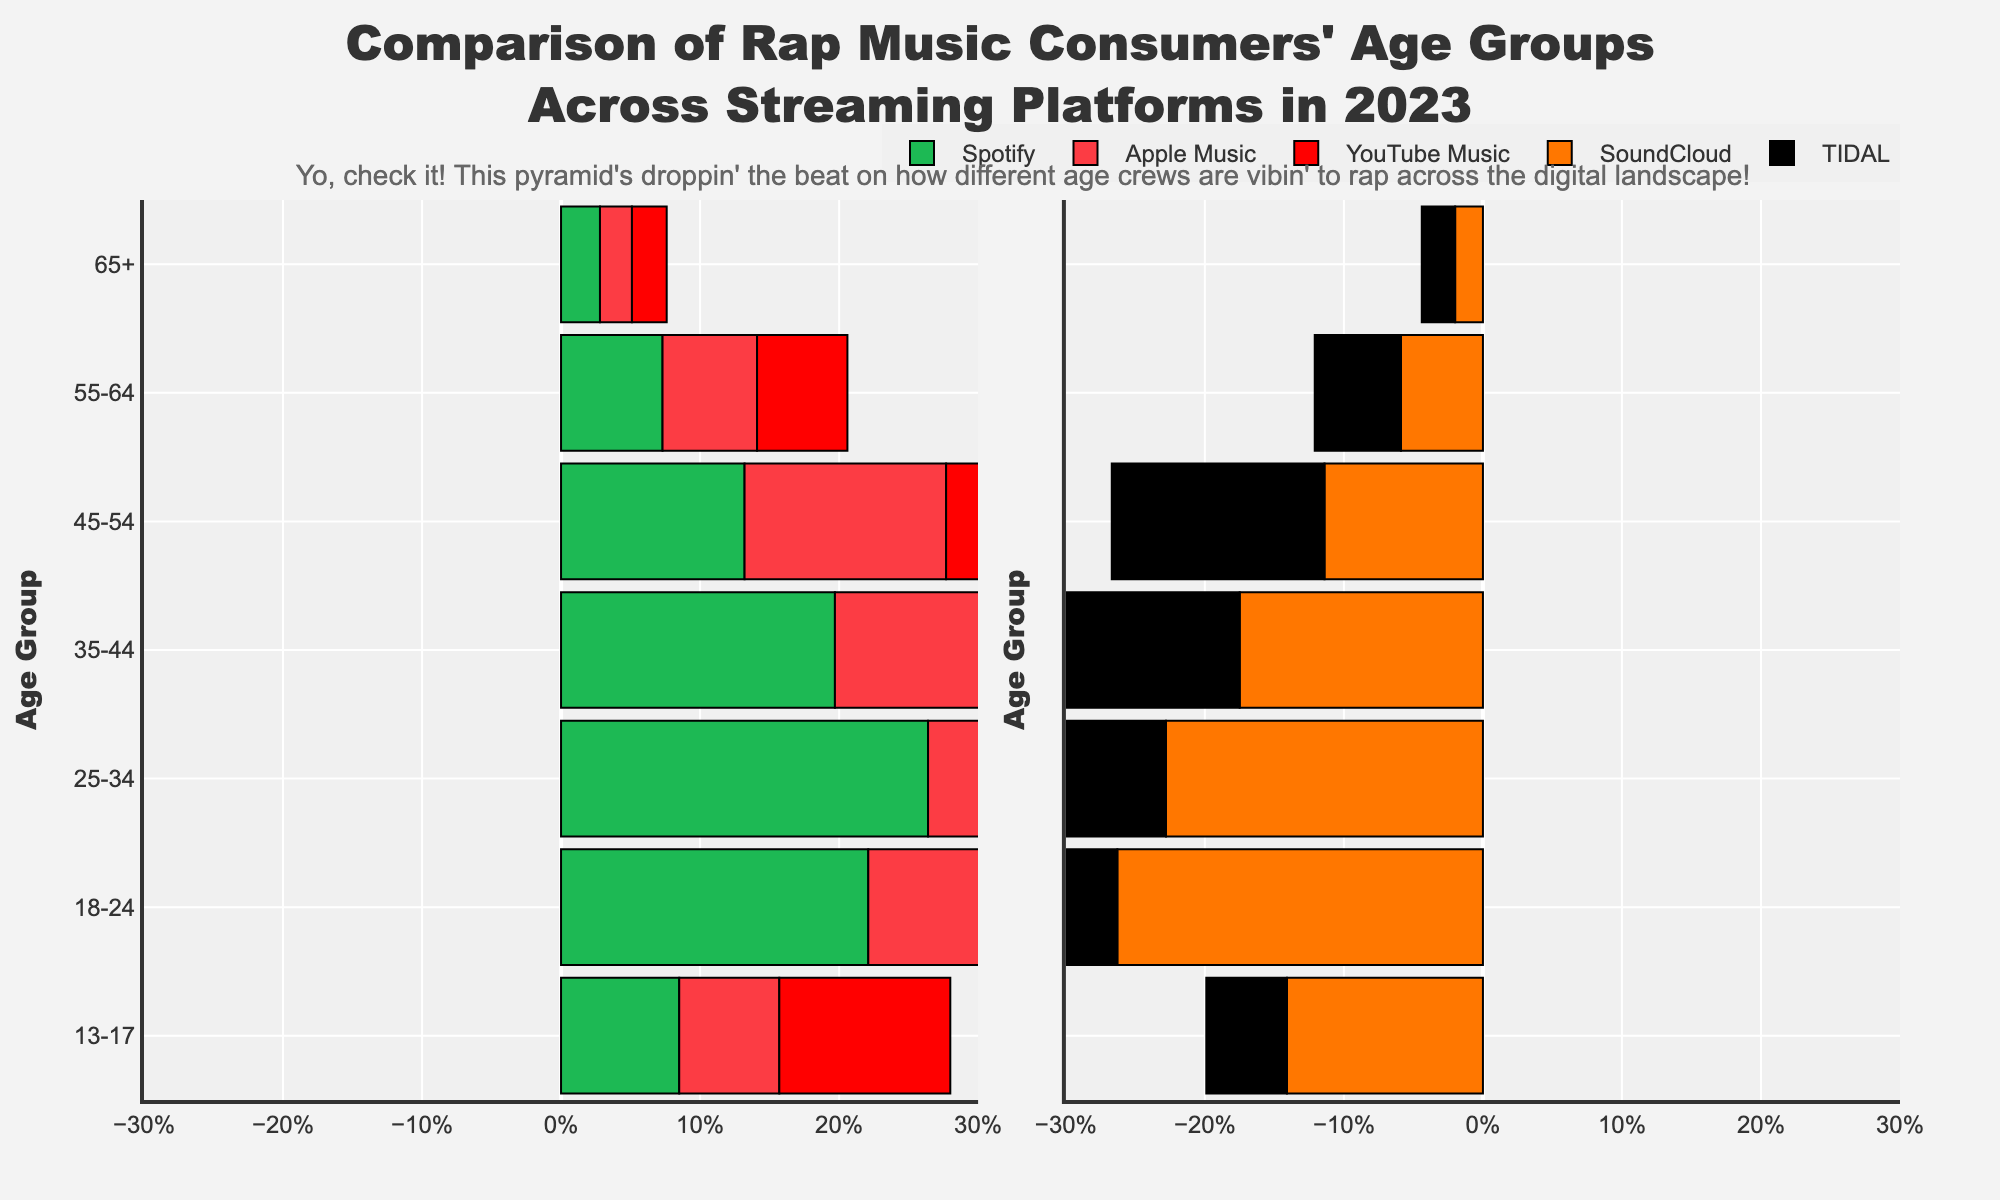What's the largest age group for Spotify listeners? Looking at the bar heights, the 25-34 age group has the highest proportion for Spotify listeners at 26.4%.
Answer: 25-34 Which platform has the lowest percentage of listeners aged 65+? For each platform, we see  Spotify (2.8%), Apple Music (2.3%), YouTube Music (2.5%), SoundCloud (2.0%), TIDAL (2.4%). SoundCloud has the lowest with 2.0%.
Answer: SoundCloud Compare the 18-24 age group between YouTube Music and TIDAL. YouTube Music has 24.5% of listeners aged 18-24, while TIDAL has 18.7% in the same group. Thus, YouTube Music has a higher percentage.
Answer: YouTube Music What's the difference in percentage of 35-44 year-old listeners between Apple Music and SoundCloud? The figure shows that Apple Music has 21.3% and SoundCloud has 17.5% for the 35-44 age group. The difference is 21.3% - 17.5% = 3.8%.
Answer: 3.8% Which age group has the smallest percentage range across all platforms? By comparing the percentages for each age group across platforms, the 65+ group has percentages 2.8%, 2.3%, 2.5%, 2.0%, and 2.4%. The range is 2.8% - 2.0% = 0.8%.
Answer: 65+ How does the percentage of 45-54 year-old SoundCloud listeners compare to the overall average for that age group? Calculate the average for the 45-54 age group across platforms: (13.2% + 14.5% + 12.1% + 11.4% + 15.3%) / 5 = 13.3%. SoundCloud has 11.4%, which is 1.9% lower than the average.
Answer: 1.9% lower What's the total percentage of Spotify listeners aged 13-34? For Spotify, add the percentages for ages 13-17 (8.5%), 18-24 (22.1%), and 25-34 (26.4%). The total is 8.5% + 22.1% + 26.4% = 57%.
Answer: 57% Does YouTube Music have more listeners aged 55-64 than TIDAL? Compare 55-64 age group: YouTube Music has 6.5% and TIDAL has 6.2%. Thus, YouTube Music has more listeners in that age group.
Answer: Yes Which platform shows a higher percentage of 13-17 year-olds compared to 35-44 year-olds? Compare both age groups for each platform: Spotify (8.5% vs. 19.7%), Apple Music (7.2% vs. 21.3%), YouTube Music (12.3% vs. 18.2%), SoundCloud (14.1% vs. 17.5%), TIDAL (5.8% vs. 22.1%). Only SoundCloud (14.1% vs. 17.5%) has a higher percentage of 13-17 year-olds than 35-44 year-olds.
Answer: SoundCloud 